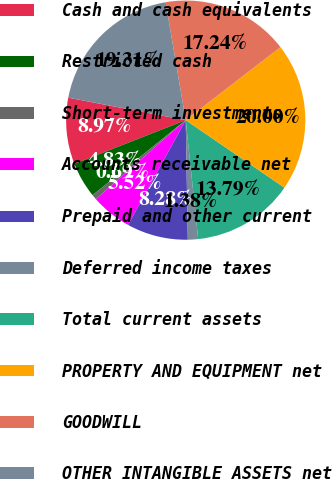<chart> <loc_0><loc_0><loc_500><loc_500><pie_chart><fcel>Cash and cash equivalents<fcel>Restricted cash<fcel>Short-term investments<fcel>Accounts receivable net<fcel>Prepaid and other current<fcel>Deferred income taxes<fcel>Total current assets<fcel>PROPERTY AND EQUIPMENT net<fcel>GOODWILL<fcel>OTHER INTANGIBLE ASSETS net<nl><fcel>8.97%<fcel>4.83%<fcel>0.69%<fcel>5.52%<fcel>8.28%<fcel>1.38%<fcel>13.79%<fcel>20.0%<fcel>17.24%<fcel>19.31%<nl></chart> 